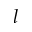Convert formula to latex. <formula><loc_0><loc_0><loc_500><loc_500>l</formula> 